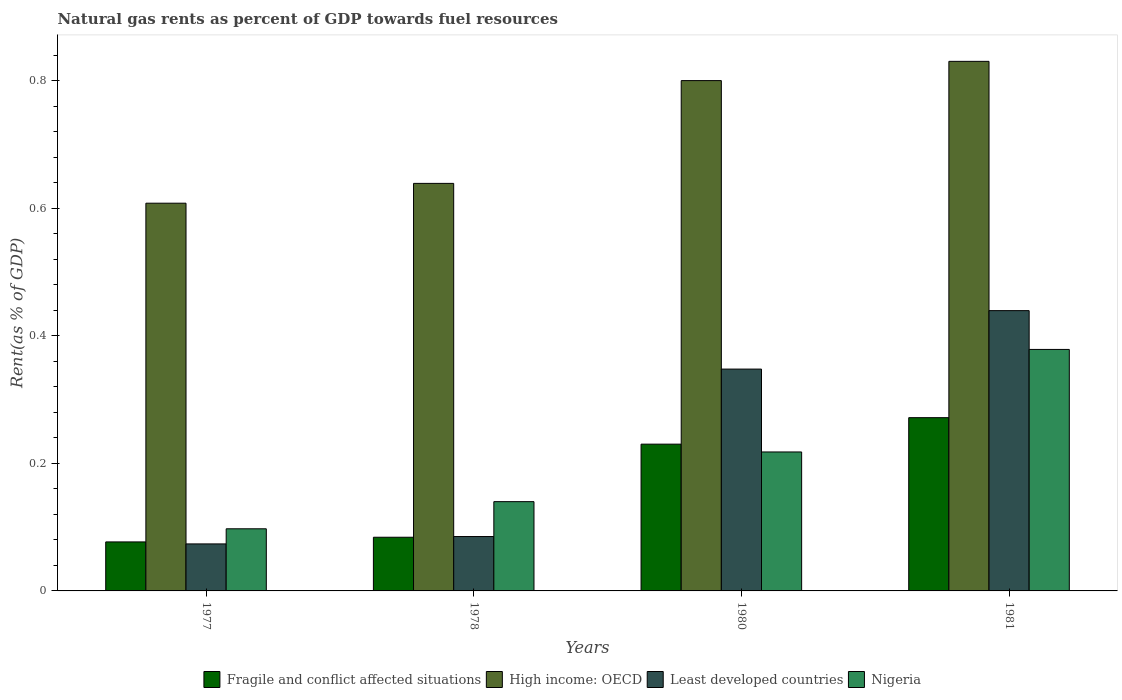How many different coloured bars are there?
Offer a terse response. 4. Are the number of bars per tick equal to the number of legend labels?
Your answer should be very brief. Yes. Are the number of bars on each tick of the X-axis equal?
Provide a short and direct response. Yes. What is the label of the 1st group of bars from the left?
Your answer should be compact. 1977. What is the matural gas rent in High income: OECD in 1980?
Offer a very short reply. 0.8. Across all years, what is the maximum matural gas rent in Least developed countries?
Provide a succinct answer. 0.44. Across all years, what is the minimum matural gas rent in Fragile and conflict affected situations?
Provide a succinct answer. 0.08. In which year was the matural gas rent in High income: OECD maximum?
Offer a terse response. 1981. What is the total matural gas rent in Fragile and conflict affected situations in the graph?
Your answer should be very brief. 0.66. What is the difference between the matural gas rent in Fragile and conflict affected situations in 1978 and that in 1980?
Keep it short and to the point. -0.15. What is the difference between the matural gas rent in Fragile and conflict affected situations in 1977 and the matural gas rent in Nigeria in 1978?
Give a very brief answer. -0.06. What is the average matural gas rent in Nigeria per year?
Offer a very short reply. 0.21. In the year 1981, what is the difference between the matural gas rent in Nigeria and matural gas rent in Least developed countries?
Offer a terse response. -0.06. What is the ratio of the matural gas rent in Nigeria in 1978 to that in 1980?
Your answer should be very brief. 0.64. Is the difference between the matural gas rent in Nigeria in 1978 and 1980 greater than the difference between the matural gas rent in Least developed countries in 1978 and 1980?
Offer a terse response. Yes. What is the difference between the highest and the second highest matural gas rent in Fragile and conflict affected situations?
Your answer should be very brief. 0.04. What is the difference between the highest and the lowest matural gas rent in Fragile and conflict affected situations?
Your answer should be very brief. 0.19. In how many years, is the matural gas rent in Fragile and conflict affected situations greater than the average matural gas rent in Fragile and conflict affected situations taken over all years?
Ensure brevity in your answer.  2. Is the sum of the matural gas rent in High income: OECD in 1978 and 1981 greater than the maximum matural gas rent in Least developed countries across all years?
Make the answer very short. Yes. Is it the case that in every year, the sum of the matural gas rent in Least developed countries and matural gas rent in Nigeria is greater than the sum of matural gas rent in Fragile and conflict affected situations and matural gas rent in High income: OECD?
Offer a terse response. No. What does the 2nd bar from the left in 1980 represents?
Keep it short and to the point. High income: OECD. What does the 4th bar from the right in 1978 represents?
Your answer should be very brief. Fragile and conflict affected situations. Are all the bars in the graph horizontal?
Your response must be concise. No. What is the difference between two consecutive major ticks on the Y-axis?
Your answer should be very brief. 0.2. Does the graph contain any zero values?
Offer a terse response. No. Does the graph contain grids?
Offer a terse response. No. Where does the legend appear in the graph?
Your response must be concise. Bottom center. How many legend labels are there?
Provide a succinct answer. 4. How are the legend labels stacked?
Keep it short and to the point. Horizontal. What is the title of the graph?
Ensure brevity in your answer.  Natural gas rents as percent of GDP towards fuel resources. Does "Nepal" appear as one of the legend labels in the graph?
Keep it short and to the point. No. What is the label or title of the Y-axis?
Provide a succinct answer. Rent(as % of GDP). What is the Rent(as % of GDP) in Fragile and conflict affected situations in 1977?
Offer a very short reply. 0.08. What is the Rent(as % of GDP) of High income: OECD in 1977?
Your answer should be compact. 0.61. What is the Rent(as % of GDP) in Least developed countries in 1977?
Keep it short and to the point. 0.07. What is the Rent(as % of GDP) in Nigeria in 1977?
Offer a very short reply. 0.1. What is the Rent(as % of GDP) of Fragile and conflict affected situations in 1978?
Make the answer very short. 0.08. What is the Rent(as % of GDP) in High income: OECD in 1978?
Give a very brief answer. 0.64. What is the Rent(as % of GDP) in Least developed countries in 1978?
Provide a succinct answer. 0.09. What is the Rent(as % of GDP) of Nigeria in 1978?
Ensure brevity in your answer.  0.14. What is the Rent(as % of GDP) of Fragile and conflict affected situations in 1980?
Make the answer very short. 0.23. What is the Rent(as % of GDP) in High income: OECD in 1980?
Provide a succinct answer. 0.8. What is the Rent(as % of GDP) of Least developed countries in 1980?
Your answer should be very brief. 0.35. What is the Rent(as % of GDP) in Nigeria in 1980?
Offer a terse response. 0.22. What is the Rent(as % of GDP) in Fragile and conflict affected situations in 1981?
Keep it short and to the point. 0.27. What is the Rent(as % of GDP) in High income: OECD in 1981?
Make the answer very short. 0.83. What is the Rent(as % of GDP) of Least developed countries in 1981?
Provide a succinct answer. 0.44. What is the Rent(as % of GDP) in Nigeria in 1981?
Offer a very short reply. 0.38. Across all years, what is the maximum Rent(as % of GDP) in Fragile and conflict affected situations?
Your response must be concise. 0.27. Across all years, what is the maximum Rent(as % of GDP) of High income: OECD?
Give a very brief answer. 0.83. Across all years, what is the maximum Rent(as % of GDP) of Least developed countries?
Offer a terse response. 0.44. Across all years, what is the maximum Rent(as % of GDP) of Nigeria?
Your answer should be compact. 0.38. Across all years, what is the minimum Rent(as % of GDP) in Fragile and conflict affected situations?
Provide a succinct answer. 0.08. Across all years, what is the minimum Rent(as % of GDP) in High income: OECD?
Give a very brief answer. 0.61. Across all years, what is the minimum Rent(as % of GDP) of Least developed countries?
Offer a terse response. 0.07. Across all years, what is the minimum Rent(as % of GDP) in Nigeria?
Offer a very short reply. 0.1. What is the total Rent(as % of GDP) of Fragile and conflict affected situations in the graph?
Your response must be concise. 0.66. What is the total Rent(as % of GDP) of High income: OECD in the graph?
Make the answer very short. 2.88. What is the total Rent(as % of GDP) in Least developed countries in the graph?
Provide a succinct answer. 0.95. What is the total Rent(as % of GDP) of Nigeria in the graph?
Provide a short and direct response. 0.83. What is the difference between the Rent(as % of GDP) in Fragile and conflict affected situations in 1977 and that in 1978?
Your answer should be very brief. -0.01. What is the difference between the Rent(as % of GDP) of High income: OECD in 1977 and that in 1978?
Offer a very short reply. -0.03. What is the difference between the Rent(as % of GDP) in Least developed countries in 1977 and that in 1978?
Offer a very short reply. -0.01. What is the difference between the Rent(as % of GDP) of Nigeria in 1977 and that in 1978?
Give a very brief answer. -0.04. What is the difference between the Rent(as % of GDP) in Fragile and conflict affected situations in 1977 and that in 1980?
Provide a succinct answer. -0.15. What is the difference between the Rent(as % of GDP) of High income: OECD in 1977 and that in 1980?
Your response must be concise. -0.19. What is the difference between the Rent(as % of GDP) of Least developed countries in 1977 and that in 1980?
Make the answer very short. -0.27. What is the difference between the Rent(as % of GDP) in Nigeria in 1977 and that in 1980?
Your answer should be very brief. -0.12. What is the difference between the Rent(as % of GDP) in Fragile and conflict affected situations in 1977 and that in 1981?
Provide a short and direct response. -0.19. What is the difference between the Rent(as % of GDP) of High income: OECD in 1977 and that in 1981?
Provide a succinct answer. -0.22. What is the difference between the Rent(as % of GDP) of Least developed countries in 1977 and that in 1981?
Provide a short and direct response. -0.37. What is the difference between the Rent(as % of GDP) of Nigeria in 1977 and that in 1981?
Provide a short and direct response. -0.28. What is the difference between the Rent(as % of GDP) in Fragile and conflict affected situations in 1978 and that in 1980?
Your answer should be very brief. -0.15. What is the difference between the Rent(as % of GDP) in High income: OECD in 1978 and that in 1980?
Offer a very short reply. -0.16. What is the difference between the Rent(as % of GDP) in Least developed countries in 1978 and that in 1980?
Make the answer very short. -0.26. What is the difference between the Rent(as % of GDP) in Nigeria in 1978 and that in 1980?
Keep it short and to the point. -0.08. What is the difference between the Rent(as % of GDP) in Fragile and conflict affected situations in 1978 and that in 1981?
Offer a terse response. -0.19. What is the difference between the Rent(as % of GDP) of High income: OECD in 1978 and that in 1981?
Keep it short and to the point. -0.19. What is the difference between the Rent(as % of GDP) of Least developed countries in 1978 and that in 1981?
Make the answer very short. -0.35. What is the difference between the Rent(as % of GDP) in Nigeria in 1978 and that in 1981?
Your response must be concise. -0.24. What is the difference between the Rent(as % of GDP) in Fragile and conflict affected situations in 1980 and that in 1981?
Provide a succinct answer. -0.04. What is the difference between the Rent(as % of GDP) in High income: OECD in 1980 and that in 1981?
Give a very brief answer. -0.03. What is the difference between the Rent(as % of GDP) in Least developed countries in 1980 and that in 1981?
Ensure brevity in your answer.  -0.09. What is the difference between the Rent(as % of GDP) in Nigeria in 1980 and that in 1981?
Provide a short and direct response. -0.16. What is the difference between the Rent(as % of GDP) of Fragile and conflict affected situations in 1977 and the Rent(as % of GDP) of High income: OECD in 1978?
Ensure brevity in your answer.  -0.56. What is the difference between the Rent(as % of GDP) of Fragile and conflict affected situations in 1977 and the Rent(as % of GDP) of Least developed countries in 1978?
Your response must be concise. -0.01. What is the difference between the Rent(as % of GDP) of Fragile and conflict affected situations in 1977 and the Rent(as % of GDP) of Nigeria in 1978?
Offer a very short reply. -0.06. What is the difference between the Rent(as % of GDP) of High income: OECD in 1977 and the Rent(as % of GDP) of Least developed countries in 1978?
Offer a terse response. 0.52. What is the difference between the Rent(as % of GDP) in High income: OECD in 1977 and the Rent(as % of GDP) in Nigeria in 1978?
Your response must be concise. 0.47. What is the difference between the Rent(as % of GDP) of Least developed countries in 1977 and the Rent(as % of GDP) of Nigeria in 1978?
Make the answer very short. -0.07. What is the difference between the Rent(as % of GDP) of Fragile and conflict affected situations in 1977 and the Rent(as % of GDP) of High income: OECD in 1980?
Your answer should be compact. -0.72. What is the difference between the Rent(as % of GDP) of Fragile and conflict affected situations in 1977 and the Rent(as % of GDP) of Least developed countries in 1980?
Make the answer very short. -0.27. What is the difference between the Rent(as % of GDP) of Fragile and conflict affected situations in 1977 and the Rent(as % of GDP) of Nigeria in 1980?
Your answer should be very brief. -0.14. What is the difference between the Rent(as % of GDP) of High income: OECD in 1977 and the Rent(as % of GDP) of Least developed countries in 1980?
Give a very brief answer. 0.26. What is the difference between the Rent(as % of GDP) in High income: OECD in 1977 and the Rent(as % of GDP) in Nigeria in 1980?
Ensure brevity in your answer.  0.39. What is the difference between the Rent(as % of GDP) of Least developed countries in 1977 and the Rent(as % of GDP) of Nigeria in 1980?
Offer a terse response. -0.14. What is the difference between the Rent(as % of GDP) in Fragile and conflict affected situations in 1977 and the Rent(as % of GDP) in High income: OECD in 1981?
Make the answer very short. -0.75. What is the difference between the Rent(as % of GDP) in Fragile and conflict affected situations in 1977 and the Rent(as % of GDP) in Least developed countries in 1981?
Ensure brevity in your answer.  -0.36. What is the difference between the Rent(as % of GDP) in Fragile and conflict affected situations in 1977 and the Rent(as % of GDP) in Nigeria in 1981?
Your answer should be very brief. -0.3. What is the difference between the Rent(as % of GDP) of High income: OECD in 1977 and the Rent(as % of GDP) of Least developed countries in 1981?
Give a very brief answer. 0.17. What is the difference between the Rent(as % of GDP) of High income: OECD in 1977 and the Rent(as % of GDP) of Nigeria in 1981?
Offer a very short reply. 0.23. What is the difference between the Rent(as % of GDP) in Least developed countries in 1977 and the Rent(as % of GDP) in Nigeria in 1981?
Offer a terse response. -0.3. What is the difference between the Rent(as % of GDP) in Fragile and conflict affected situations in 1978 and the Rent(as % of GDP) in High income: OECD in 1980?
Keep it short and to the point. -0.72. What is the difference between the Rent(as % of GDP) in Fragile and conflict affected situations in 1978 and the Rent(as % of GDP) in Least developed countries in 1980?
Your answer should be very brief. -0.26. What is the difference between the Rent(as % of GDP) in Fragile and conflict affected situations in 1978 and the Rent(as % of GDP) in Nigeria in 1980?
Keep it short and to the point. -0.13. What is the difference between the Rent(as % of GDP) in High income: OECD in 1978 and the Rent(as % of GDP) in Least developed countries in 1980?
Your response must be concise. 0.29. What is the difference between the Rent(as % of GDP) in High income: OECD in 1978 and the Rent(as % of GDP) in Nigeria in 1980?
Make the answer very short. 0.42. What is the difference between the Rent(as % of GDP) in Least developed countries in 1978 and the Rent(as % of GDP) in Nigeria in 1980?
Your answer should be compact. -0.13. What is the difference between the Rent(as % of GDP) in Fragile and conflict affected situations in 1978 and the Rent(as % of GDP) in High income: OECD in 1981?
Your response must be concise. -0.75. What is the difference between the Rent(as % of GDP) in Fragile and conflict affected situations in 1978 and the Rent(as % of GDP) in Least developed countries in 1981?
Provide a short and direct response. -0.36. What is the difference between the Rent(as % of GDP) of Fragile and conflict affected situations in 1978 and the Rent(as % of GDP) of Nigeria in 1981?
Provide a short and direct response. -0.29. What is the difference between the Rent(as % of GDP) in High income: OECD in 1978 and the Rent(as % of GDP) in Least developed countries in 1981?
Provide a succinct answer. 0.2. What is the difference between the Rent(as % of GDP) in High income: OECD in 1978 and the Rent(as % of GDP) in Nigeria in 1981?
Ensure brevity in your answer.  0.26. What is the difference between the Rent(as % of GDP) of Least developed countries in 1978 and the Rent(as % of GDP) of Nigeria in 1981?
Keep it short and to the point. -0.29. What is the difference between the Rent(as % of GDP) in Fragile and conflict affected situations in 1980 and the Rent(as % of GDP) in High income: OECD in 1981?
Your answer should be very brief. -0.6. What is the difference between the Rent(as % of GDP) in Fragile and conflict affected situations in 1980 and the Rent(as % of GDP) in Least developed countries in 1981?
Offer a terse response. -0.21. What is the difference between the Rent(as % of GDP) of Fragile and conflict affected situations in 1980 and the Rent(as % of GDP) of Nigeria in 1981?
Your answer should be compact. -0.15. What is the difference between the Rent(as % of GDP) of High income: OECD in 1980 and the Rent(as % of GDP) of Least developed countries in 1981?
Offer a terse response. 0.36. What is the difference between the Rent(as % of GDP) of High income: OECD in 1980 and the Rent(as % of GDP) of Nigeria in 1981?
Give a very brief answer. 0.42. What is the difference between the Rent(as % of GDP) of Least developed countries in 1980 and the Rent(as % of GDP) of Nigeria in 1981?
Give a very brief answer. -0.03. What is the average Rent(as % of GDP) of Fragile and conflict affected situations per year?
Your response must be concise. 0.17. What is the average Rent(as % of GDP) in High income: OECD per year?
Your response must be concise. 0.72. What is the average Rent(as % of GDP) of Least developed countries per year?
Your response must be concise. 0.24. What is the average Rent(as % of GDP) in Nigeria per year?
Provide a short and direct response. 0.21. In the year 1977, what is the difference between the Rent(as % of GDP) of Fragile and conflict affected situations and Rent(as % of GDP) of High income: OECD?
Your answer should be compact. -0.53. In the year 1977, what is the difference between the Rent(as % of GDP) of Fragile and conflict affected situations and Rent(as % of GDP) of Least developed countries?
Keep it short and to the point. 0. In the year 1977, what is the difference between the Rent(as % of GDP) in Fragile and conflict affected situations and Rent(as % of GDP) in Nigeria?
Your answer should be very brief. -0.02. In the year 1977, what is the difference between the Rent(as % of GDP) of High income: OECD and Rent(as % of GDP) of Least developed countries?
Offer a terse response. 0.53. In the year 1977, what is the difference between the Rent(as % of GDP) in High income: OECD and Rent(as % of GDP) in Nigeria?
Ensure brevity in your answer.  0.51. In the year 1977, what is the difference between the Rent(as % of GDP) in Least developed countries and Rent(as % of GDP) in Nigeria?
Your answer should be very brief. -0.02. In the year 1978, what is the difference between the Rent(as % of GDP) in Fragile and conflict affected situations and Rent(as % of GDP) in High income: OECD?
Offer a very short reply. -0.55. In the year 1978, what is the difference between the Rent(as % of GDP) in Fragile and conflict affected situations and Rent(as % of GDP) in Least developed countries?
Your response must be concise. -0. In the year 1978, what is the difference between the Rent(as % of GDP) in Fragile and conflict affected situations and Rent(as % of GDP) in Nigeria?
Offer a terse response. -0.06. In the year 1978, what is the difference between the Rent(as % of GDP) of High income: OECD and Rent(as % of GDP) of Least developed countries?
Provide a short and direct response. 0.55. In the year 1978, what is the difference between the Rent(as % of GDP) of High income: OECD and Rent(as % of GDP) of Nigeria?
Provide a succinct answer. 0.5. In the year 1978, what is the difference between the Rent(as % of GDP) of Least developed countries and Rent(as % of GDP) of Nigeria?
Your answer should be very brief. -0.05. In the year 1980, what is the difference between the Rent(as % of GDP) of Fragile and conflict affected situations and Rent(as % of GDP) of High income: OECD?
Ensure brevity in your answer.  -0.57. In the year 1980, what is the difference between the Rent(as % of GDP) of Fragile and conflict affected situations and Rent(as % of GDP) of Least developed countries?
Make the answer very short. -0.12. In the year 1980, what is the difference between the Rent(as % of GDP) of Fragile and conflict affected situations and Rent(as % of GDP) of Nigeria?
Your response must be concise. 0.01. In the year 1980, what is the difference between the Rent(as % of GDP) in High income: OECD and Rent(as % of GDP) in Least developed countries?
Your answer should be very brief. 0.45. In the year 1980, what is the difference between the Rent(as % of GDP) in High income: OECD and Rent(as % of GDP) in Nigeria?
Your answer should be very brief. 0.58. In the year 1980, what is the difference between the Rent(as % of GDP) in Least developed countries and Rent(as % of GDP) in Nigeria?
Give a very brief answer. 0.13. In the year 1981, what is the difference between the Rent(as % of GDP) in Fragile and conflict affected situations and Rent(as % of GDP) in High income: OECD?
Your answer should be compact. -0.56. In the year 1981, what is the difference between the Rent(as % of GDP) of Fragile and conflict affected situations and Rent(as % of GDP) of Least developed countries?
Ensure brevity in your answer.  -0.17. In the year 1981, what is the difference between the Rent(as % of GDP) of Fragile and conflict affected situations and Rent(as % of GDP) of Nigeria?
Offer a very short reply. -0.11. In the year 1981, what is the difference between the Rent(as % of GDP) of High income: OECD and Rent(as % of GDP) of Least developed countries?
Provide a short and direct response. 0.39. In the year 1981, what is the difference between the Rent(as % of GDP) of High income: OECD and Rent(as % of GDP) of Nigeria?
Make the answer very short. 0.45. In the year 1981, what is the difference between the Rent(as % of GDP) of Least developed countries and Rent(as % of GDP) of Nigeria?
Give a very brief answer. 0.06. What is the ratio of the Rent(as % of GDP) of Fragile and conflict affected situations in 1977 to that in 1978?
Your response must be concise. 0.91. What is the ratio of the Rent(as % of GDP) of High income: OECD in 1977 to that in 1978?
Offer a terse response. 0.95. What is the ratio of the Rent(as % of GDP) of Least developed countries in 1977 to that in 1978?
Your response must be concise. 0.86. What is the ratio of the Rent(as % of GDP) of Nigeria in 1977 to that in 1978?
Your answer should be very brief. 0.7. What is the ratio of the Rent(as % of GDP) in Fragile and conflict affected situations in 1977 to that in 1980?
Keep it short and to the point. 0.33. What is the ratio of the Rent(as % of GDP) of High income: OECD in 1977 to that in 1980?
Offer a terse response. 0.76. What is the ratio of the Rent(as % of GDP) of Least developed countries in 1977 to that in 1980?
Provide a short and direct response. 0.21. What is the ratio of the Rent(as % of GDP) in Nigeria in 1977 to that in 1980?
Ensure brevity in your answer.  0.45. What is the ratio of the Rent(as % of GDP) of Fragile and conflict affected situations in 1977 to that in 1981?
Keep it short and to the point. 0.28. What is the ratio of the Rent(as % of GDP) of High income: OECD in 1977 to that in 1981?
Offer a very short reply. 0.73. What is the ratio of the Rent(as % of GDP) in Least developed countries in 1977 to that in 1981?
Give a very brief answer. 0.17. What is the ratio of the Rent(as % of GDP) in Nigeria in 1977 to that in 1981?
Make the answer very short. 0.26. What is the ratio of the Rent(as % of GDP) in Fragile and conflict affected situations in 1978 to that in 1980?
Provide a short and direct response. 0.37. What is the ratio of the Rent(as % of GDP) in High income: OECD in 1978 to that in 1980?
Your answer should be very brief. 0.8. What is the ratio of the Rent(as % of GDP) in Least developed countries in 1978 to that in 1980?
Your response must be concise. 0.25. What is the ratio of the Rent(as % of GDP) of Nigeria in 1978 to that in 1980?
Your answer should be compact. 0.64. What is the ratio of the Rent(as % of GDP) of Fragile and conflict affected situations in 1978 to that in 1981?
Offer a terse response. 0.31. What is the ratio of the Rent(as % of GDP) in High income: OECD in 1978 to that in 1981?
Keep it short and to the point. 0.77. What is the ratio of the Rent(as % of GDP) in Least developed countries in 1978 to that in 1981?
Keep it short and to the point. 0.19. What is the ratio of the Rent(as % of GDP) in Nigeria in 1978 to that in 1981?
Provide a short and direct response. 0.37. What is the ratio of the Rent(as % of GDP) of Fragile and conflict affected situations in 1980 to that in 1981?
Make the answer very short. 0.85. What is the ratio of the Rent(as % of GDP) in High income: OECD in 1980 to that in 1981?
Offer a very short reply. 0.96. What is the ratio of the Rent(as % of GDP) of Least developed countries in 1980 to that in 1981?
Offer a terse response. 0.79. What is the ratio of the Rent(as % of GDP) of Nigeria in 1980 to that in 1981?
Give a very brief answer. 0.58. What is the difference between the highest and the second highest Rent(as % of GDP) in Fragile and conflict affected situations?
Ensure brevity in your answer.  0.04. What is the difference between the highest and the second highest Rent(as % of GDP) of High income: OECD?
Give a very brief answer. 0.03. What is the difference between the highest and the second highest Rent(as % of GDP) of Least developed countries?
Your answer should be very brief. 0.09. What is the difference between the highest and the second highest Rent(as % of GDP) of Nigeria?
Provide a succinct answer. 0.16. What is the difference between the highest and the lowest Rent(as % of GDP) of Fragile and conflict affected situations?
Your response must be concise. 0.19. What is the difference between the highest and the lowest Rent(as % of GDP) in High income: OECD?
Your response must be concise. 0.22. What is the difference between the highest and the lowest Rent(as % of GDP) in Least developed countries?
Your answer should be compact. 0.37. What is the difference between the highest and the lowest Rent(as % of GDP) of Nigeria?
Give a very brief answer. 0.28. 